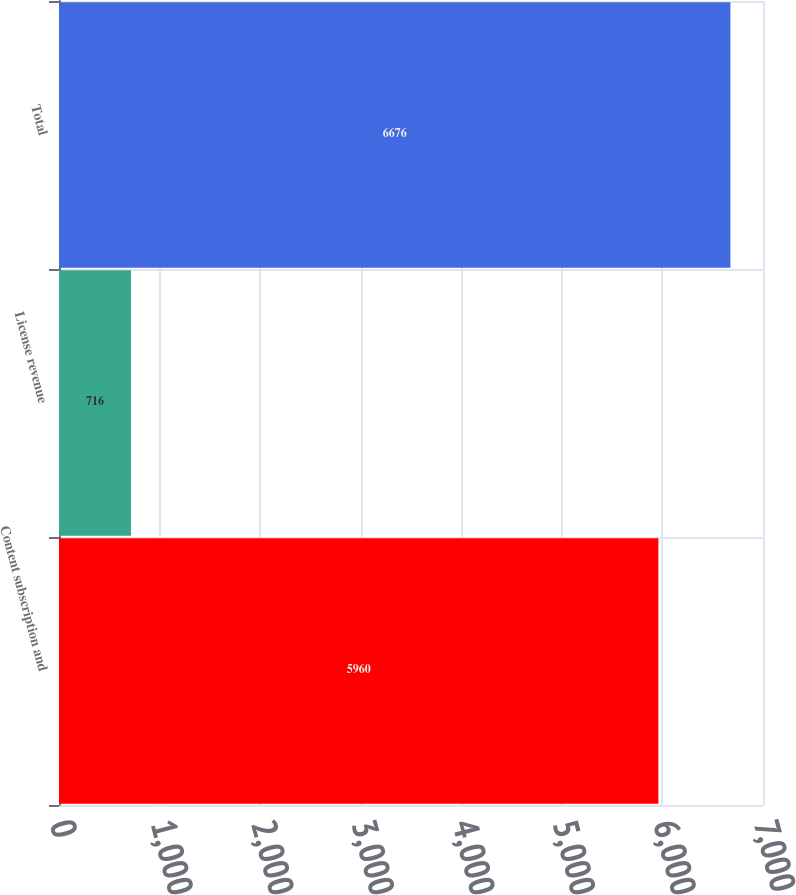Convert chart. <chart><loc_0><loc_0><loc_500><loc_500><bar_chart><fcel>Content subscription and<fcel>License revenue<fcel>Total<nl><fcel>5960<fcel>716<fcel>6676<nl></chart> 